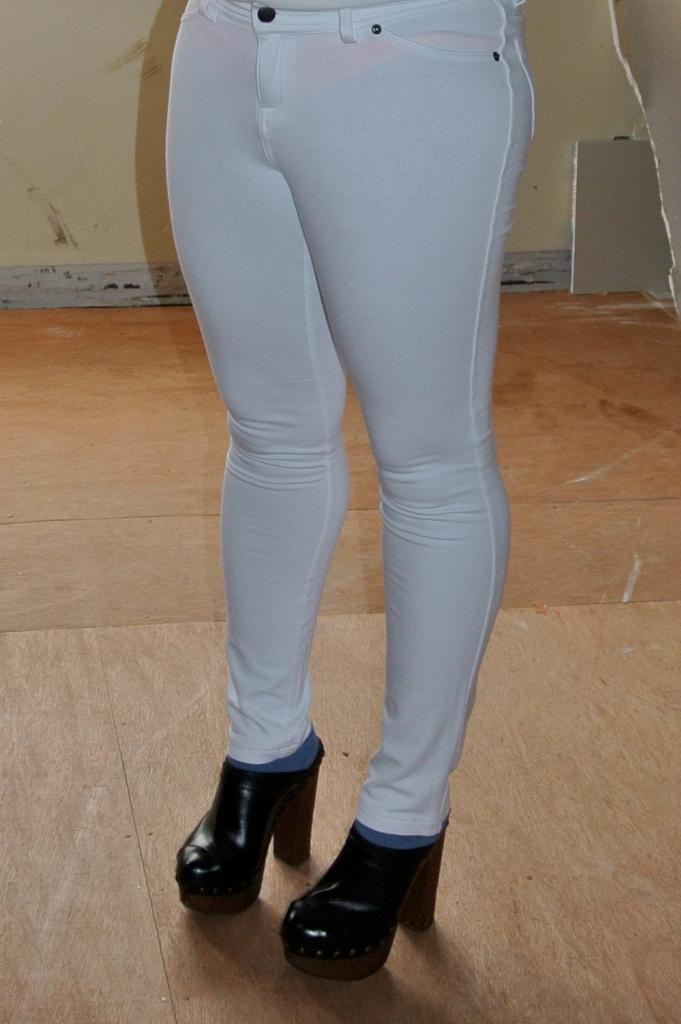Describe this image in one or two sentences. In the center of the image we can see a person legs and wearing heels. At the top of the image wall is there. In the background of the image floor is there. 